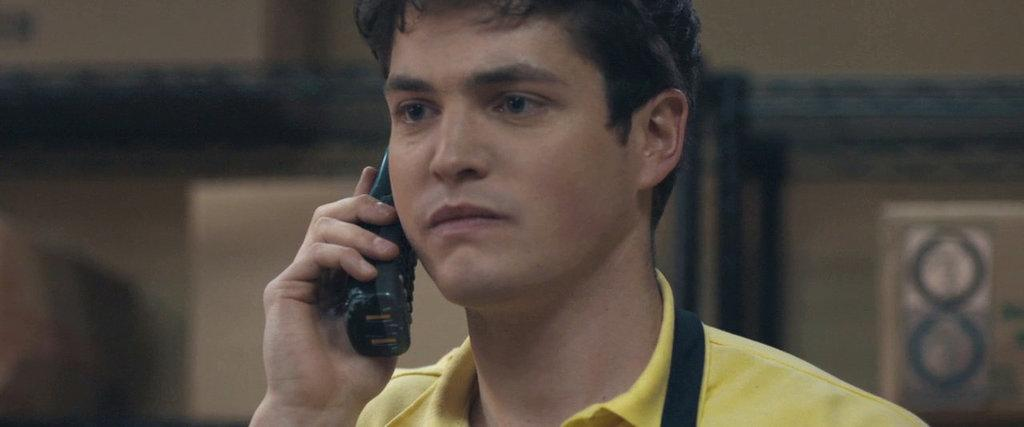Who is present in the image? There is a man in the image. What is the man holding in the image? The man is holding a phone. Can you describe the background of the image? The background of the image is blurry. What type of band can be heard playing in the background of the image? There is no band orchestra or band present in the image, and therefore no music can be heard. 